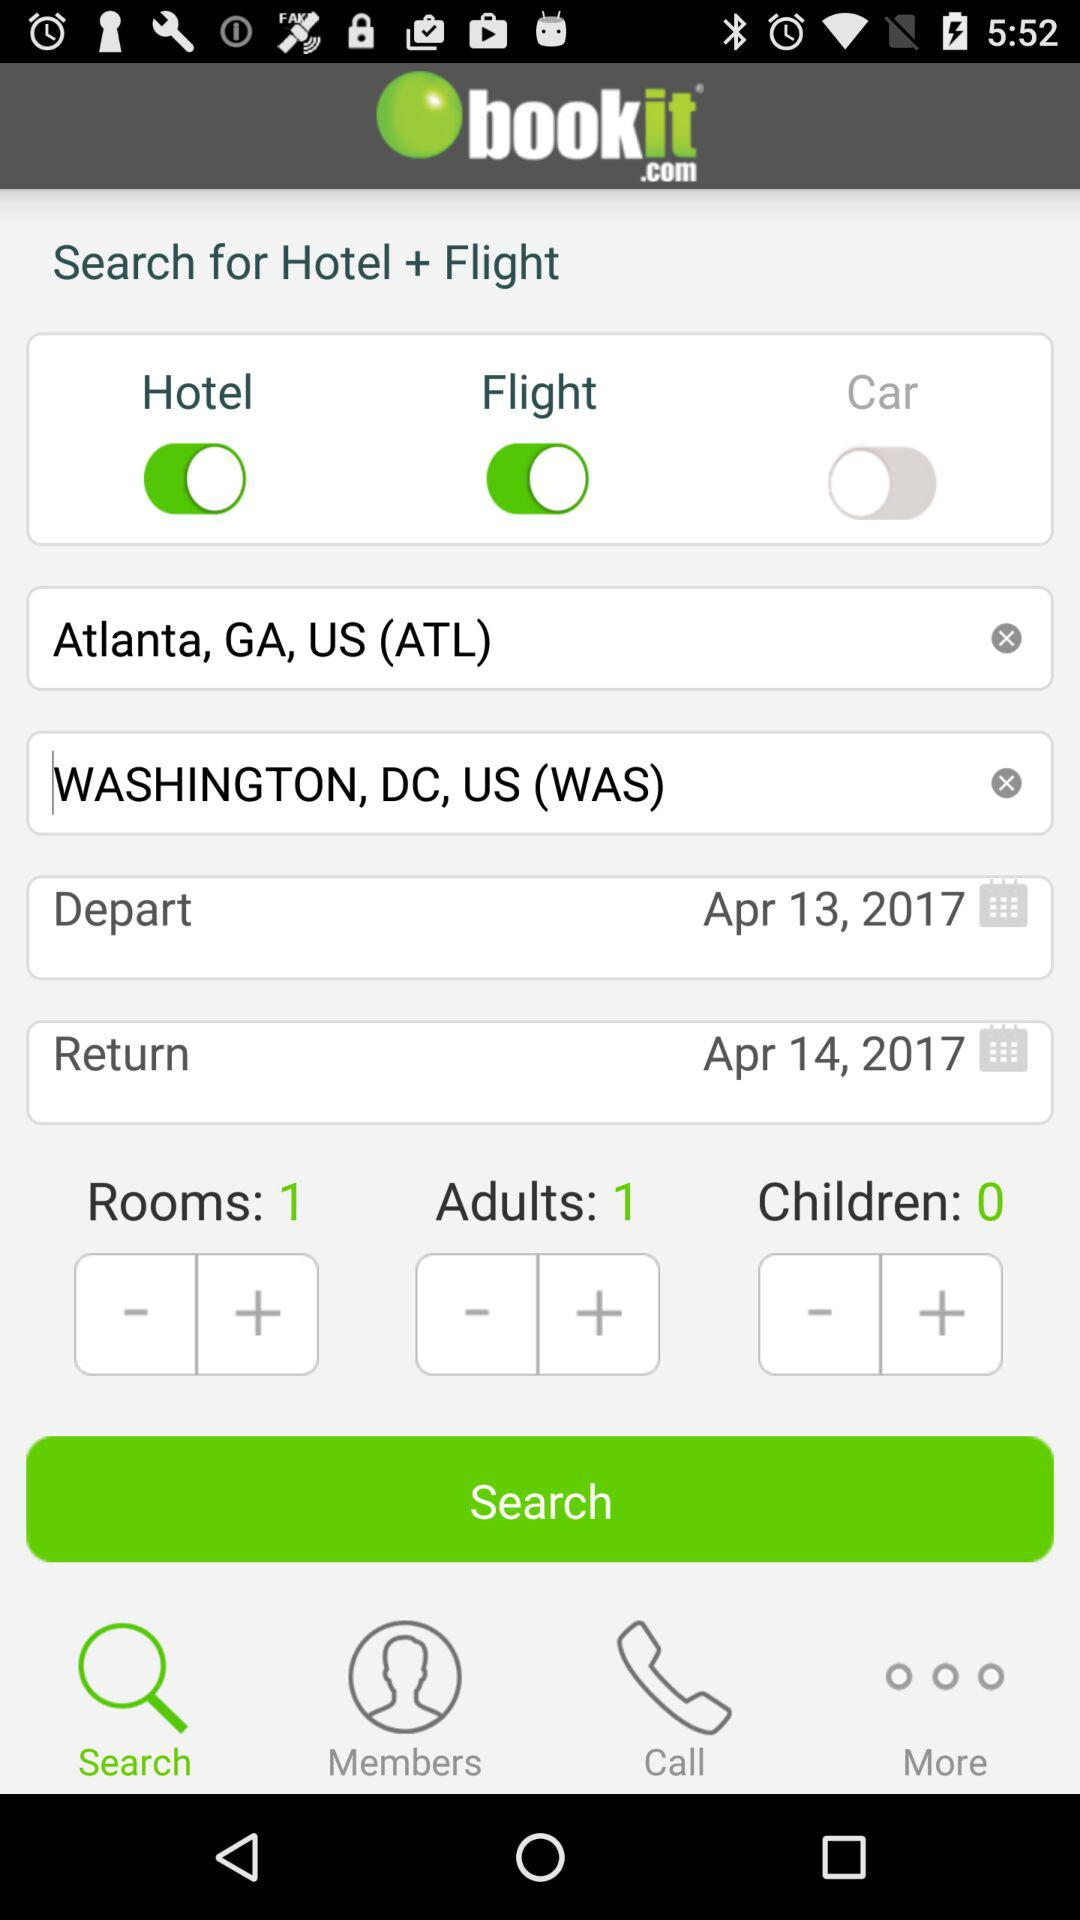What is the number of children? The number of children is 0. 